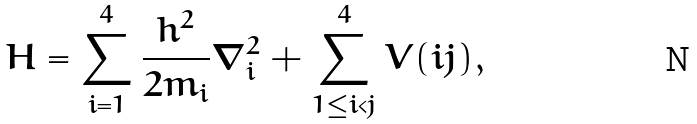Convert formula to latex. <formula><loc_0><loc_0><loc_500><loc_500>H = \sum _ { i = 1 } ^ { 4 } \frac { h ^ { 2 } } { 2 m _ { i } } \nabla ^ { 2 } _ { i } + \sum _ { 1 \leq i < j } ^ { 4 } V ( i j ) ,</formula> 